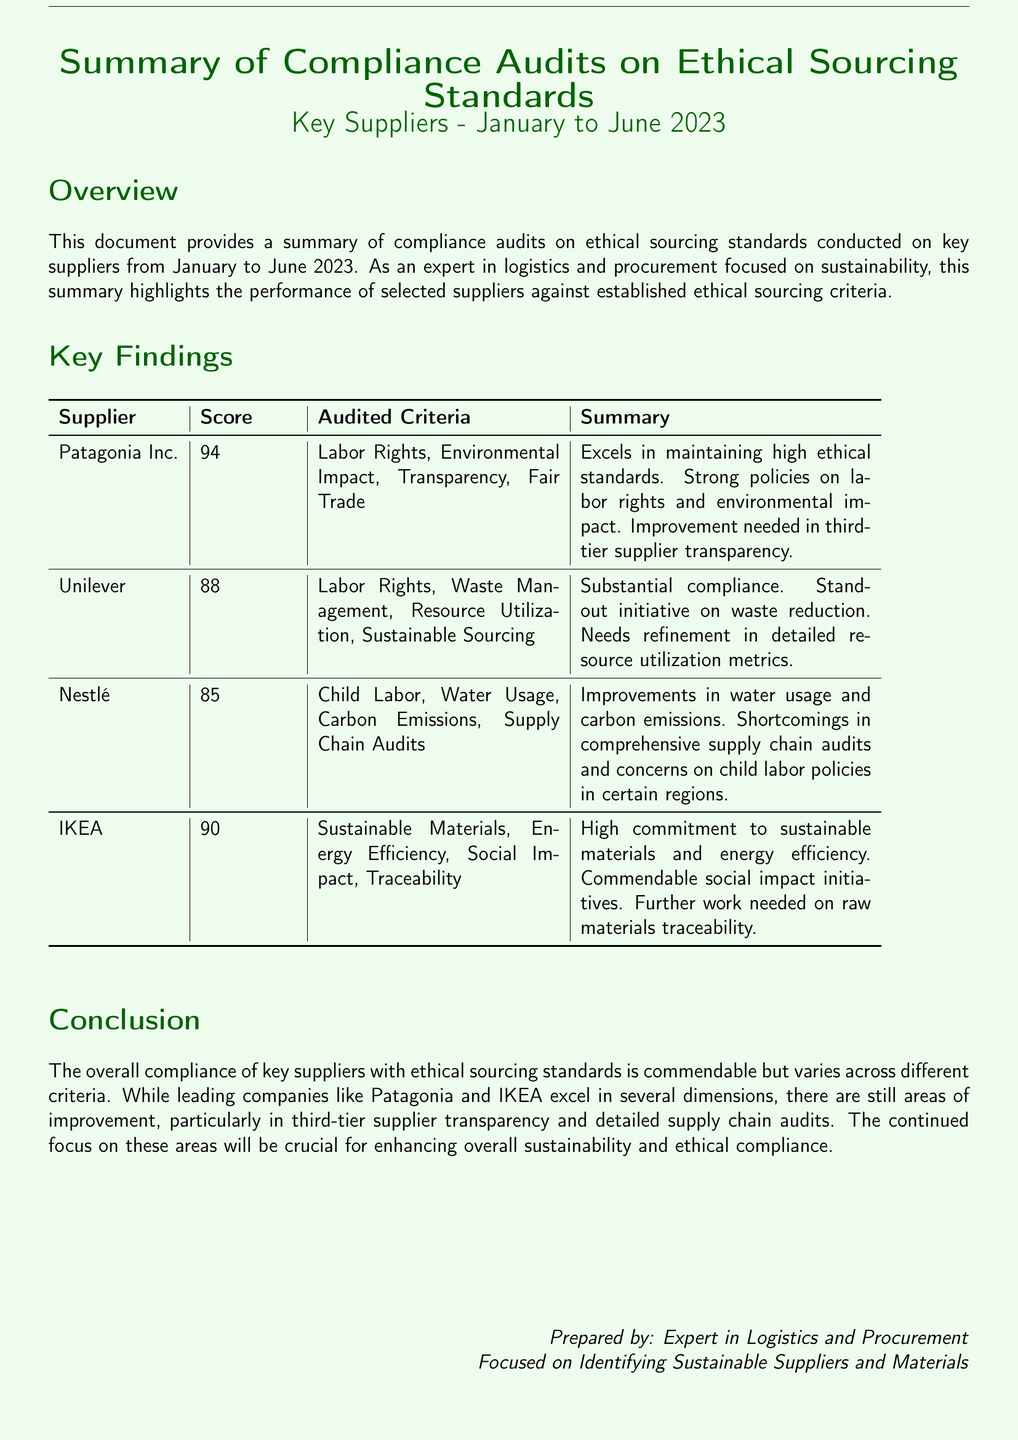What is the highest score achieved by a supplier? The highest score is listed in the findings table, which is 94 for Patagonia Inc.
Answer: 94 What criteria did Unilever score on? The audited criteria for Unilever can be found in the table, which includes Labor Rights, Waste Management, Resource Utilization, and Sustainable Sourcing.
Answer: Labor Rights, Waste Management, Resource Utilization, Sustainable Sourcing Which supplier showed improvement needed in third-tier supplier transparency? The summary section notes Patagonia Inc. requires improvement in third-tier supplier transparency.
Answer: Patagonia Inc What overall trend is highlighted in the Conclusion section? The conclusion mentions that overall compliance varies across different criteria among key suppliers.
Answer: Varies Which supplier has a commendable initiative on waste reduction? The document states that Unilever has a standout initiative on waste reduction.
Answer: Unilever What does IKEA need further work on according to the findings? The summary for IKEA highlights the need for further work on raw materials traceability.
Answer: Raw materials traceability How many suppliers were audited in total? The table lists four suppliers, indicating that four were audited.
Answer: Four What month does the compliance audit report cover up to? The document specifies that the audits cover up to June 2023.
Answer: June 2023 Which supplier excels in maintaining high ethical standards? According to the findings, Patagonia Inc. excels in this area.
Answer: Patagonia Inc 